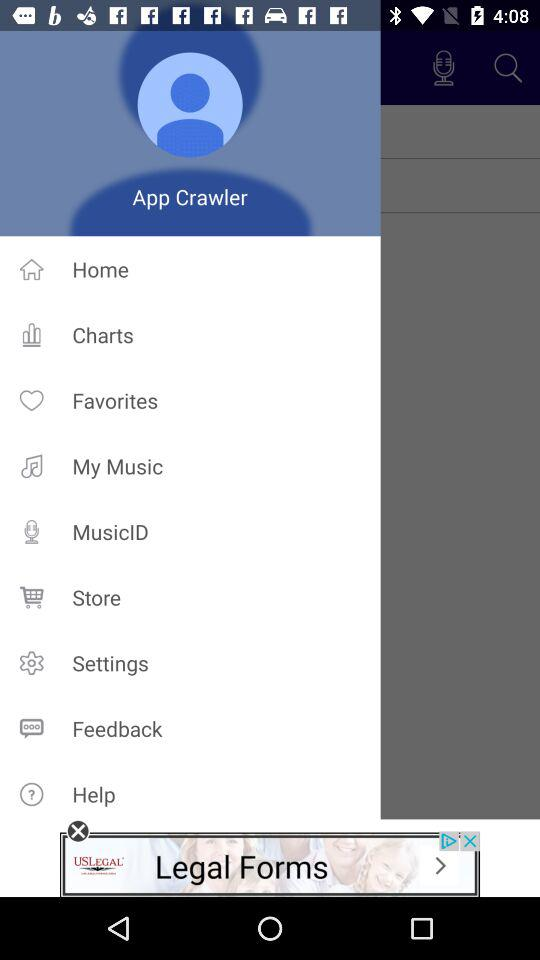What is the name of the user? The name of the user is App Crawler. 